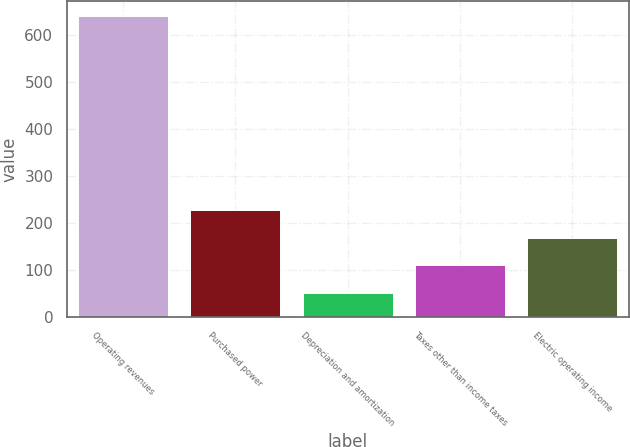Convert chart to OTSL. <chart><loc_0><loc_0><loc_500><loc_500><bar_chart><fcel>Operating revenues<fcel>Purchased power<fcel>Depreciation and amortization<fcel>Taxes other than income taxes<fcel>Electric operating income<nl><fcel>642<fcel>228.3<fcel>51<fcel>110.1<fcel>169.2<nl></chart> 